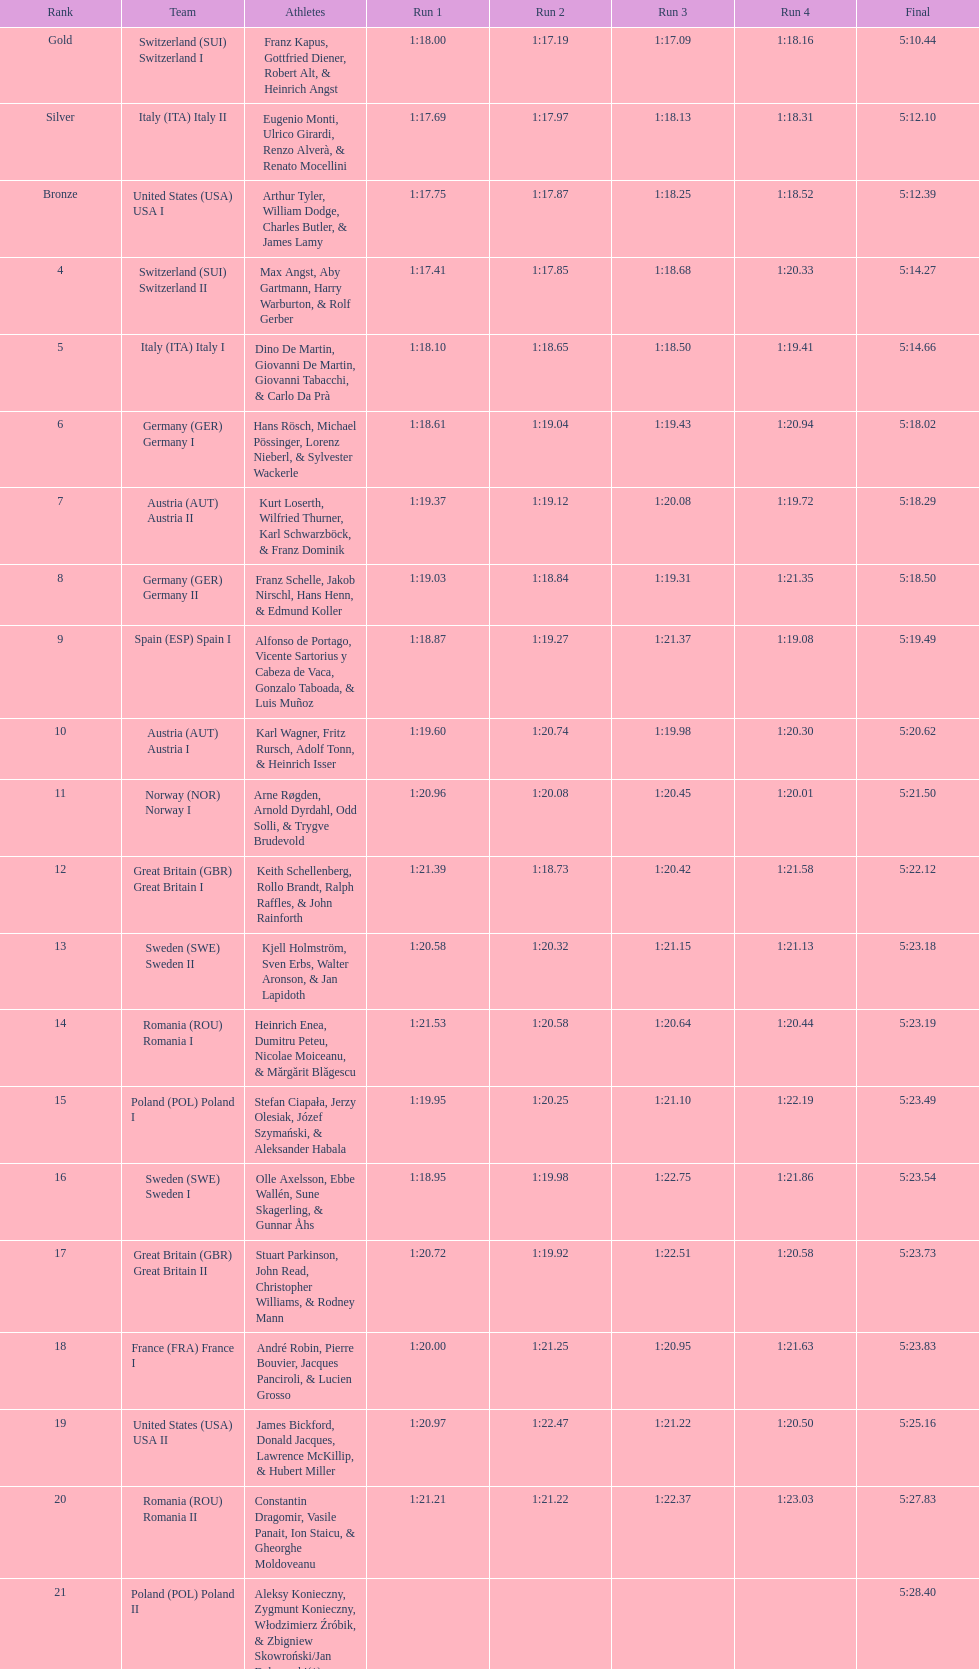Who placed the highest, italy or germany? Italy. 